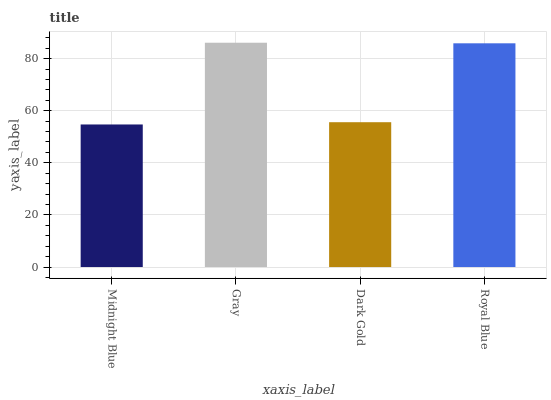Is Midnight Blue the minimum?
Answer yes or no. Yes. Is Gray the maximum?
Answer yes or no. Yes. Is Dark Gold the minimum?
Answer yes or no. No. Is Dark Gold the maximum?
Answer yes or no. No. Is Gray greater than Dark Gold?
Answer yes or no. Yes. Is Dark Gold less than Gray?
Answer yes or no. Yes. Is Dark Gold greater than Gray?
Answer yes or no. No. Is Gray less than Dark Gold?
Answer yes or no. No. Is Royal Blue the high median?
Answer yes or no. Yes. Is Dark Gold the low median?
Answer yes or no. Yes. Is Gray the high median?
Answer yes or no. No. Is Royal Blue the low median?
Answer yes or no. No. 